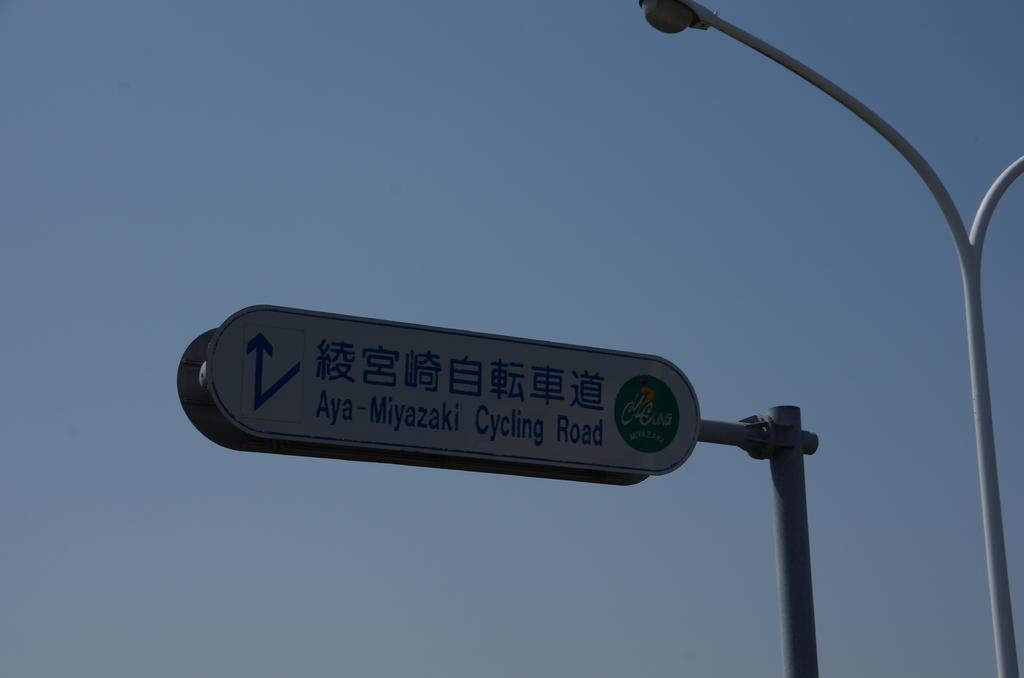What object is located on the right side of the image? There is a pole on the right side of the image. What can be seen in the center of the image? There is a sign board in the center of the image. What is visible in the background of the image? The sky is visible in the background of the image. Is there a group of people gathered around the pole, expressing their hate towards the sign board in the image? There is no mention of people or any emotions in the image. The image only shows a pole, a sign board, and the sky in the background. 